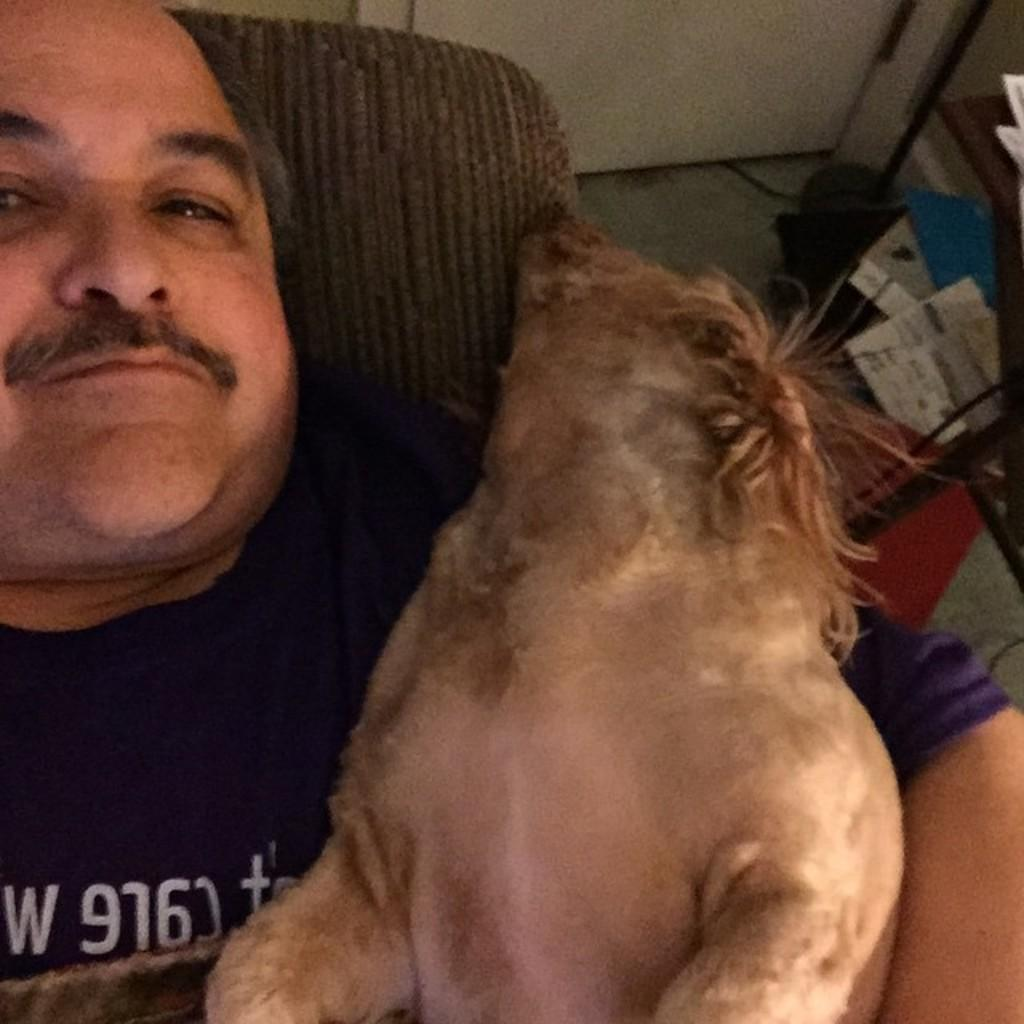What is the main subject of the image? There is a man in the image. What is the man doing in the image? The man is lying on a chair. Is there any interaction between the man and an animal in the image? Yes, the man is holding a dog. What items related to reading can be seen in the image? There are papers and books in the image. Where are the papers and books located in the image? The papers and books are on a stand. What type of cheese is being used to plough the field in the image? There is no cheese or plough present in the image. What kind of coach is the man driving in the image? There is no coach or driving activity depicted in the image. 